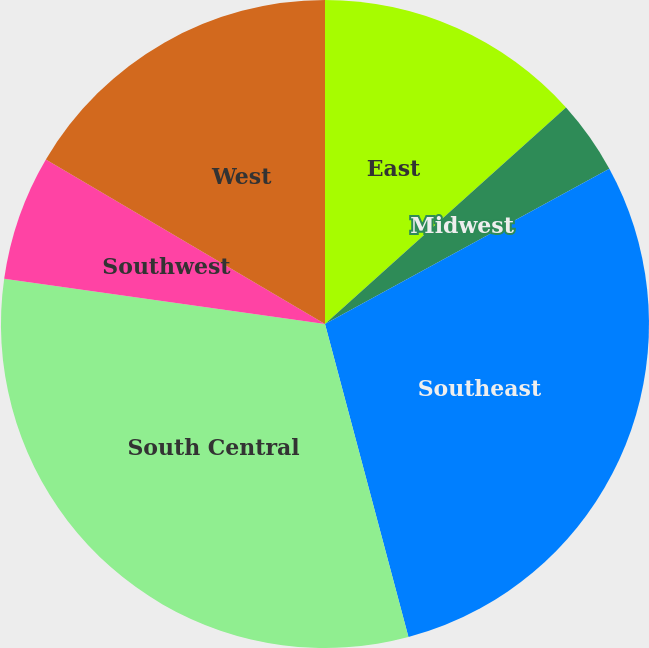Convert chart to OTSL. <chart><loc_0><loc_0><loc_500><loc_500><pie_chart><fcel>East<fcel>Midwest<fcel>Southeast<fcel>South Central<fcel>Southwest<fcel>West<nl><fcel>13.35%<fcel>3.69%<fcel>28.81%<fcel>31.37%<fcel>6.25%<fcel>16.52%<nl></chart> 